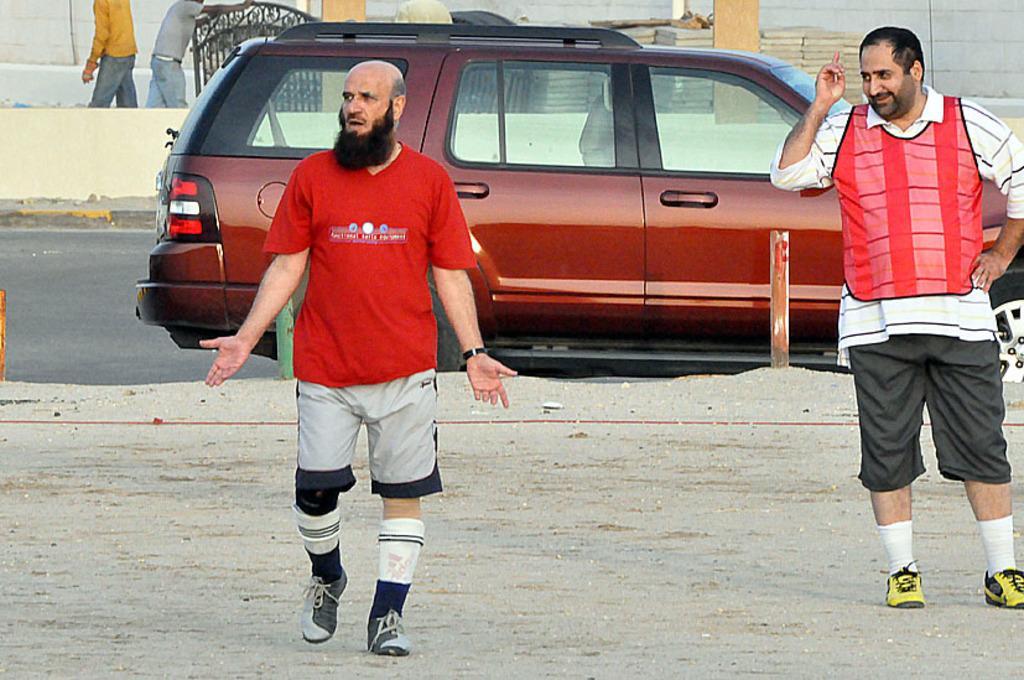Describe this image in one or two sentences. In this image, we can see people and in the background, there is a vehicle on the road and we can see some poles, agate, some stones, pillars and some other people and there is a wall and we can see a rope on the ground. 